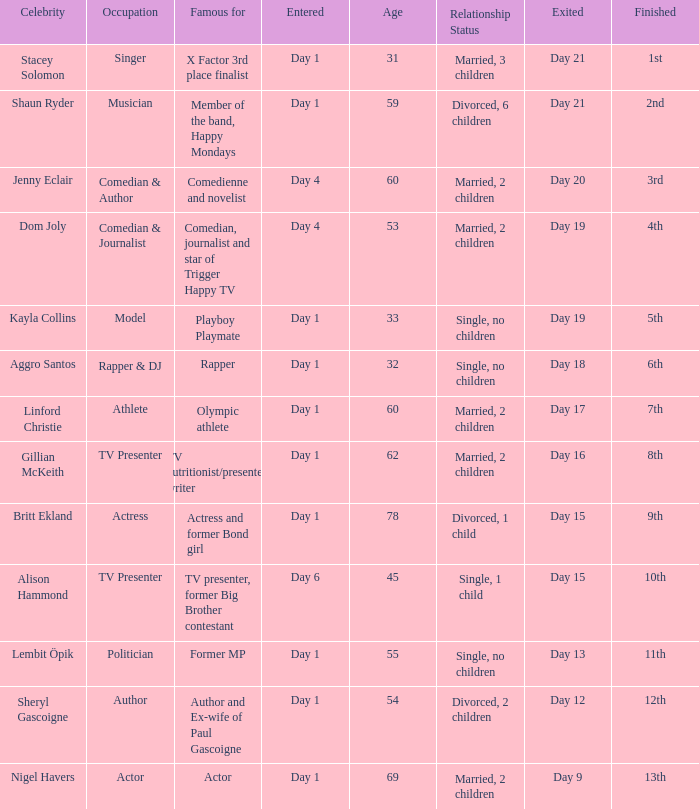What celebrity is famous for being an actor? Nigel Havers. 